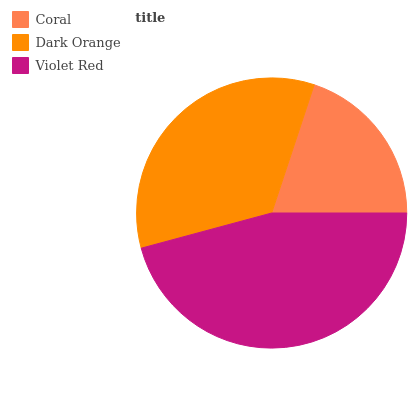Is Coral the minimum?
Answer yes or no. Yes. Is Violet Red the maximum?
Answer yes or no. Yes. Is Dark Orange the minimum?
Answer yes or no. No. Is Dark Orange the maximum?
Answer yes or no. No. Is Dark Orange greater than Coral?
Answer yes or no. Yes. Is Coral less than Dark Orange?
Answer yes or no. Yes. Is Coral greater than Dark Orange?
Answer yes or no. No. Is Dark Orange less than Coral?
Answer yes or no. No. Is Dark Orange the high median?
Answer yes or no. Yes. Is Dark Orange the low median?
Answer yes or no. Yes. Is Violet Red the high median?
Answer yes or no. No. Is Violet Red the low median?
Answer yes or no. No. 